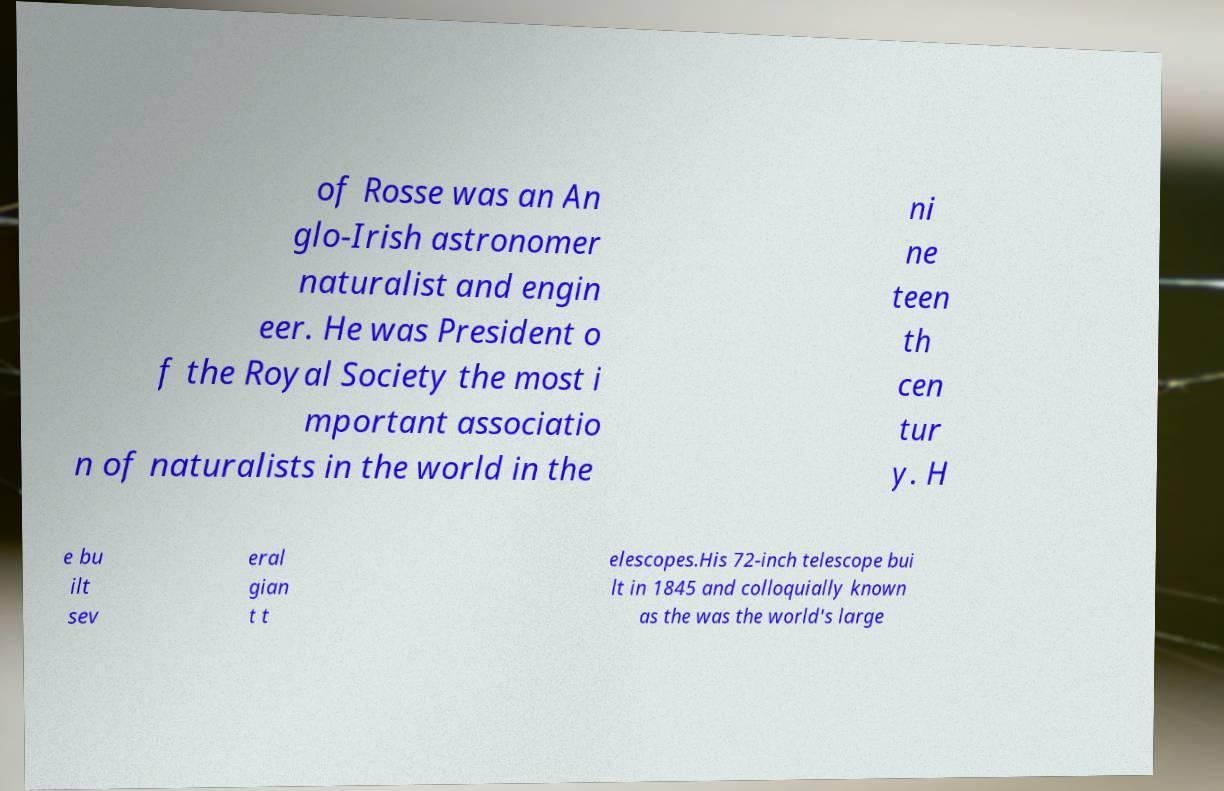Could you assist in decoding the text presented in this image and type it out clearly? of Rosse was an An glo-Irish astronomer naturalist and engin eer. He was President o f the Royal Society the most i mportant associatio n of naturalists in the world in the ni ne teen th cen tur y. H e bu ilt sev eral gian t t elescopes.His 72-inch telescope bui lt in 1845 and colloquially known as the was the world's large 